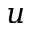<formula> <loc_0><loc_0><loc_500><loc_500>u</formula> 